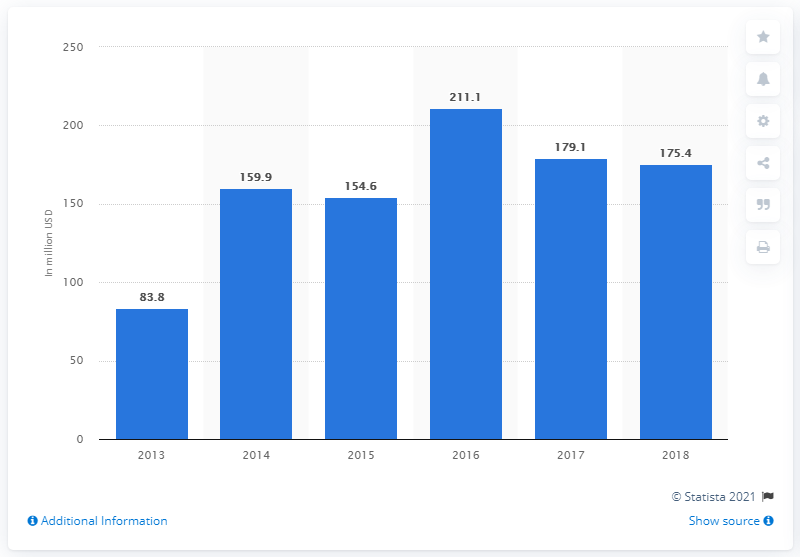What was the total transaction value of reward-based crowdfunding in the United States in 2018?
 175.4 